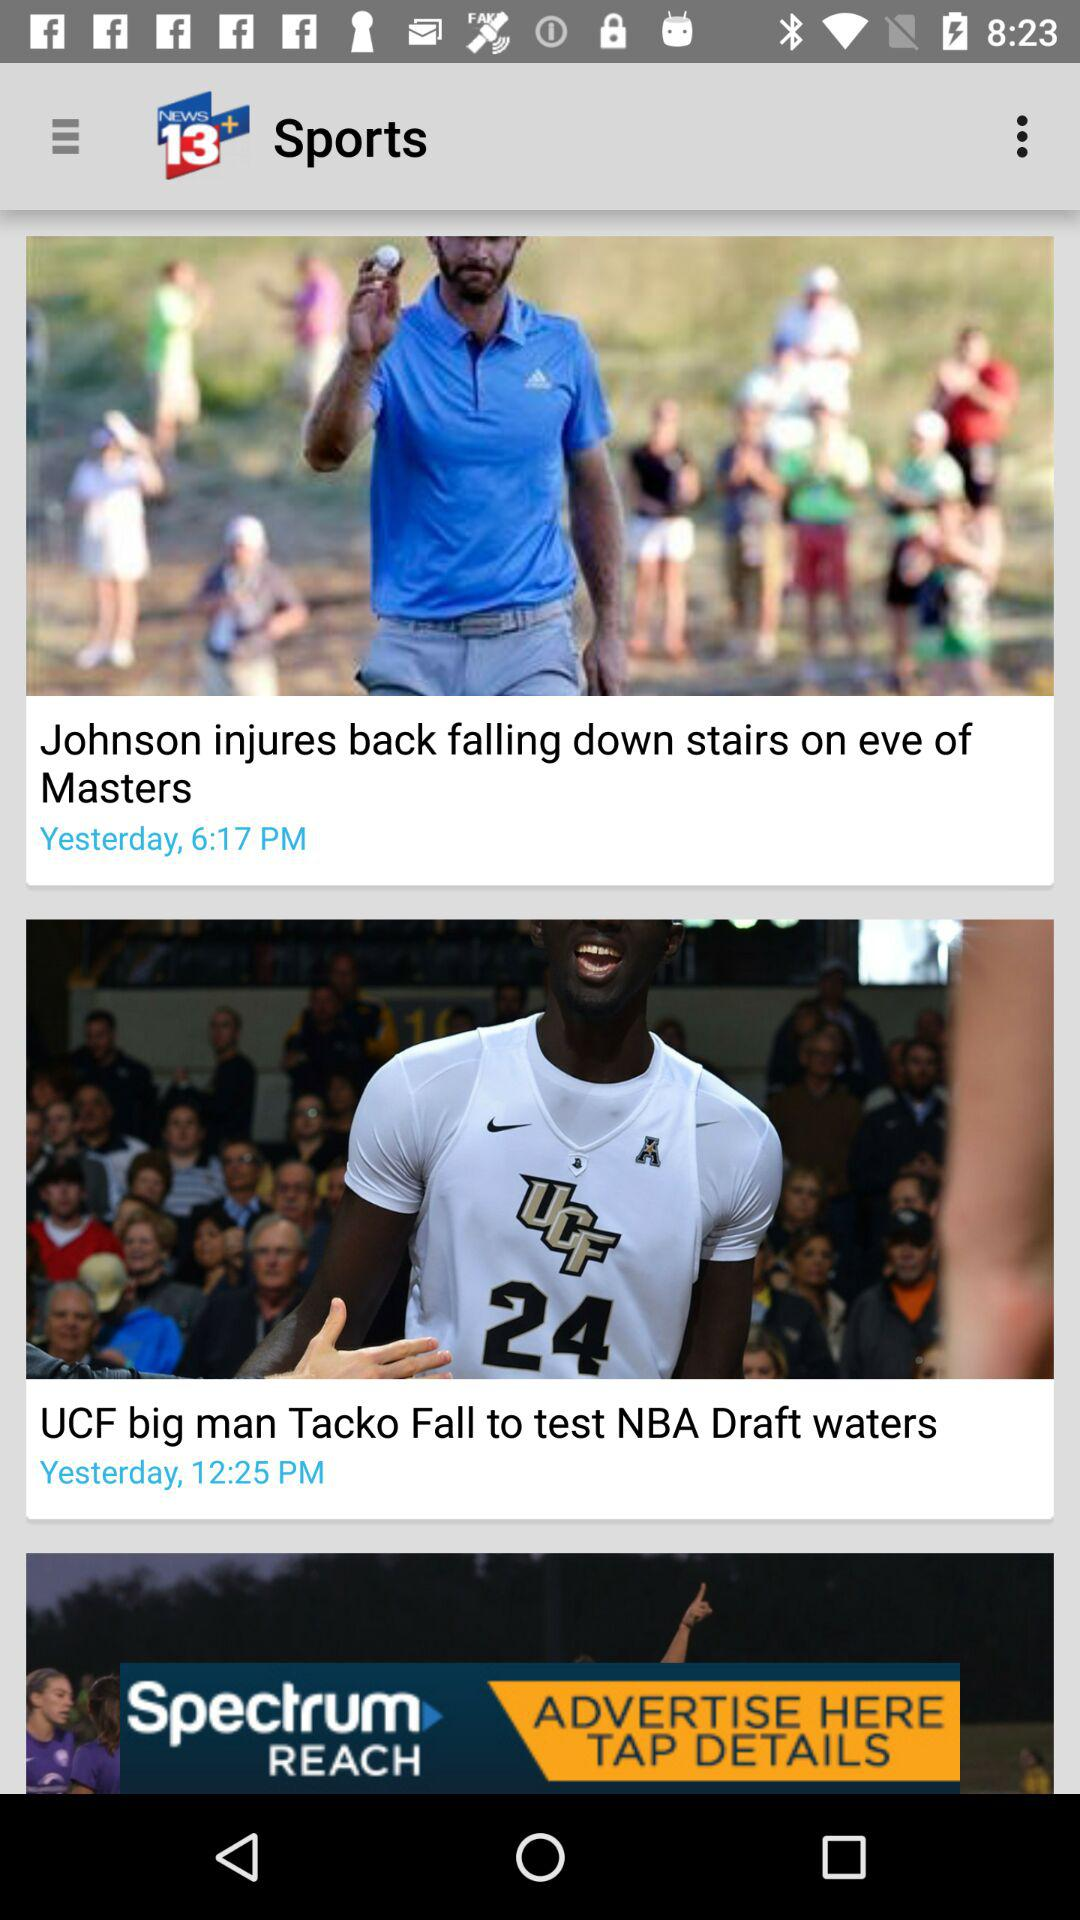When was the news "UCF big man Tacko Fall to test NBA Draft waters" posted? The news was posted yesterday at 12:25 PM. 